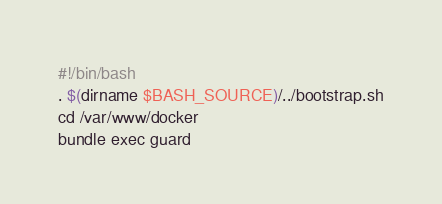Convert code to text. <code><loc_0><loc_0><loc_500><loc_500><_Bash_>#!/bin/bash
. $(dirname $BASH_SOURCE)/../bootstrap.sh
cd /var/www/docker
bundle exec guard</code> 